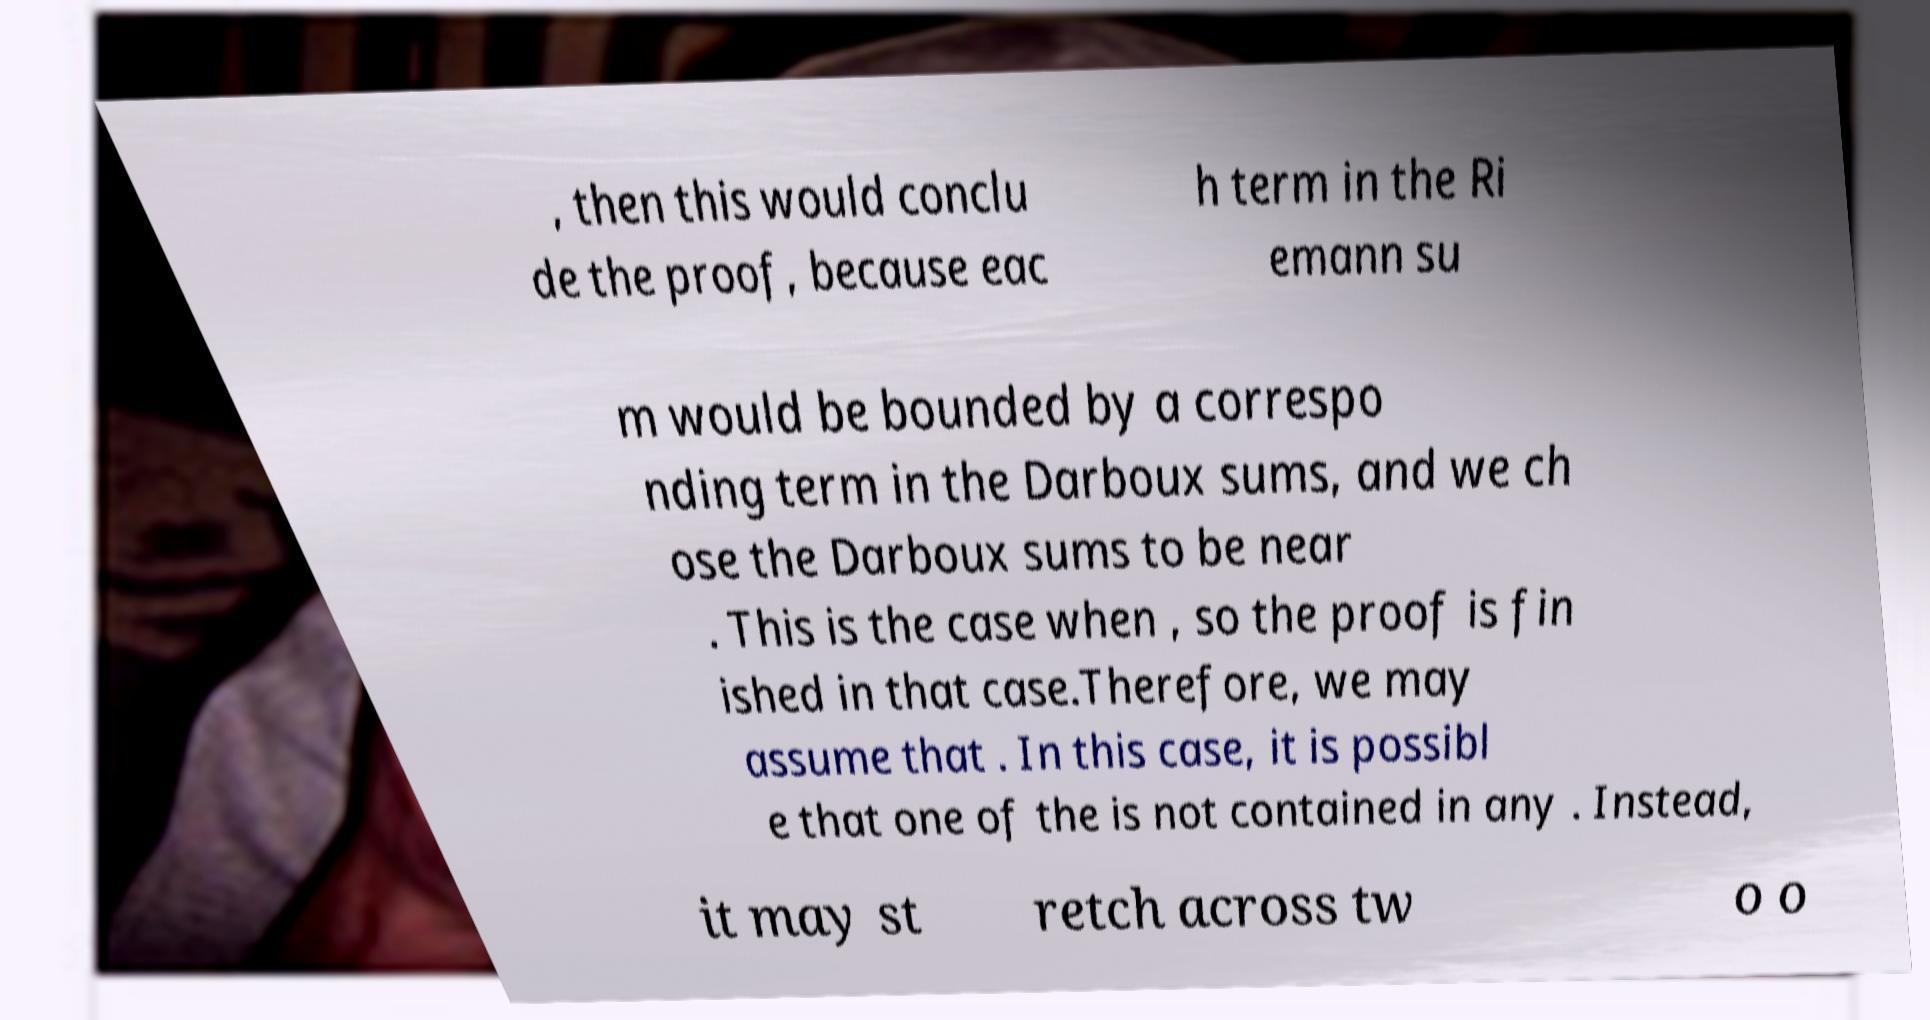There's text embedded in this image that I need extracted. Can you transcribe it verbatim? , then this would conclu de the proof, because eac h term in the Ri emann su m would be bounded by a correspo nding term in the Darboux sums, and we ch ose the Darboux sums to be near . This is the case when , so the proof is fin ished in that case.Therefore, we may assume that . In this case, it is possibl e that one of the is not contained in any . Instead, it may st retch across tw o o 